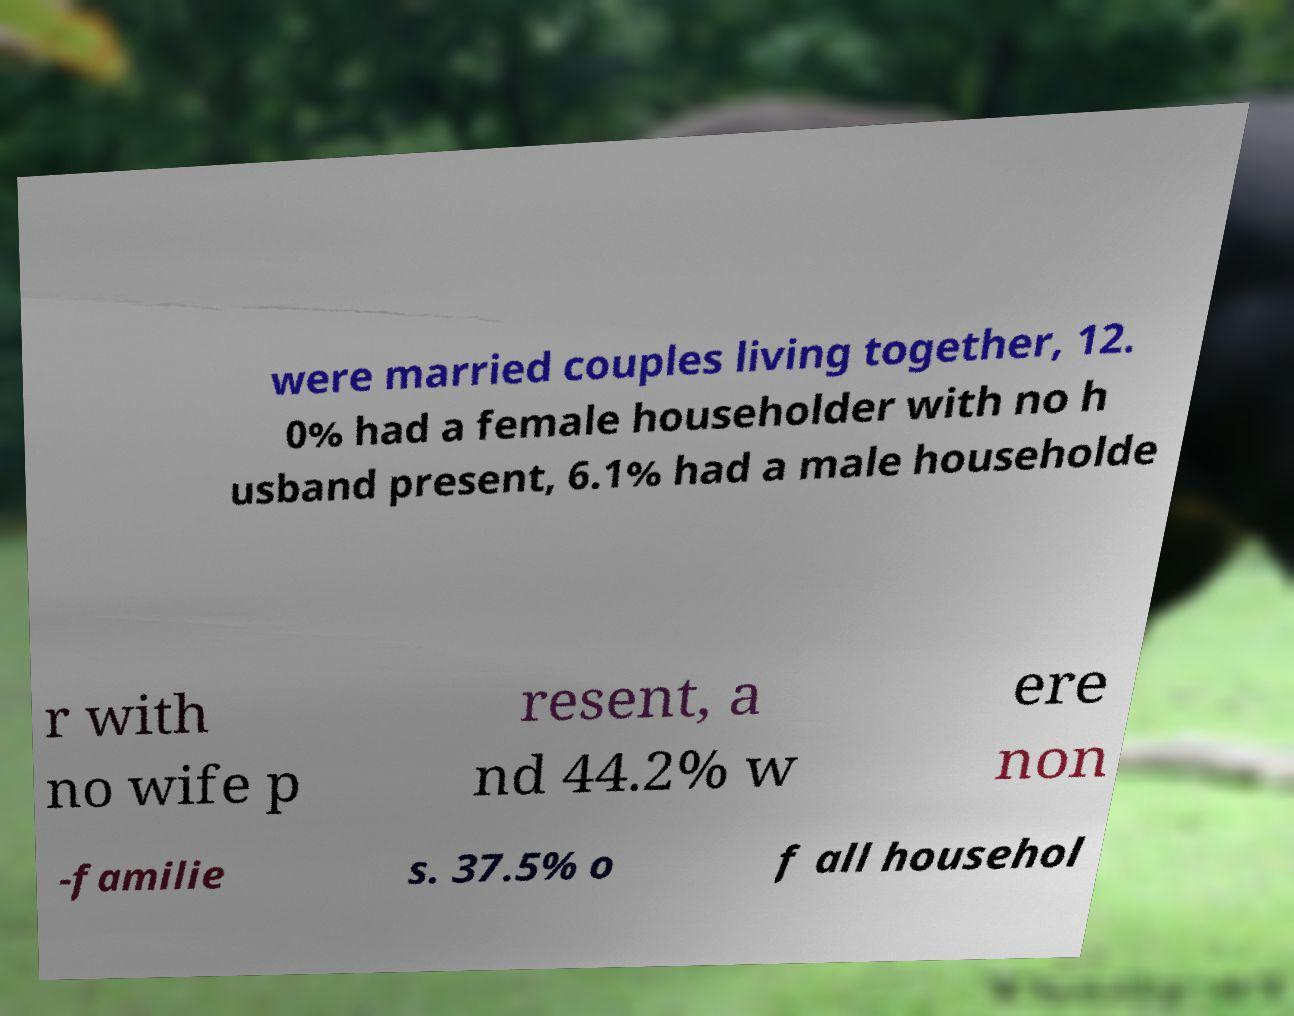Could you assist in decoding the text presented in this image and type it out clearly? were married couples living together, 12. 0% had a female householder with no h usband present, 6.1% had a male householde r with no wife p resent, a nd 44.2% w ere non -familie s. 37.5% o f all househol 